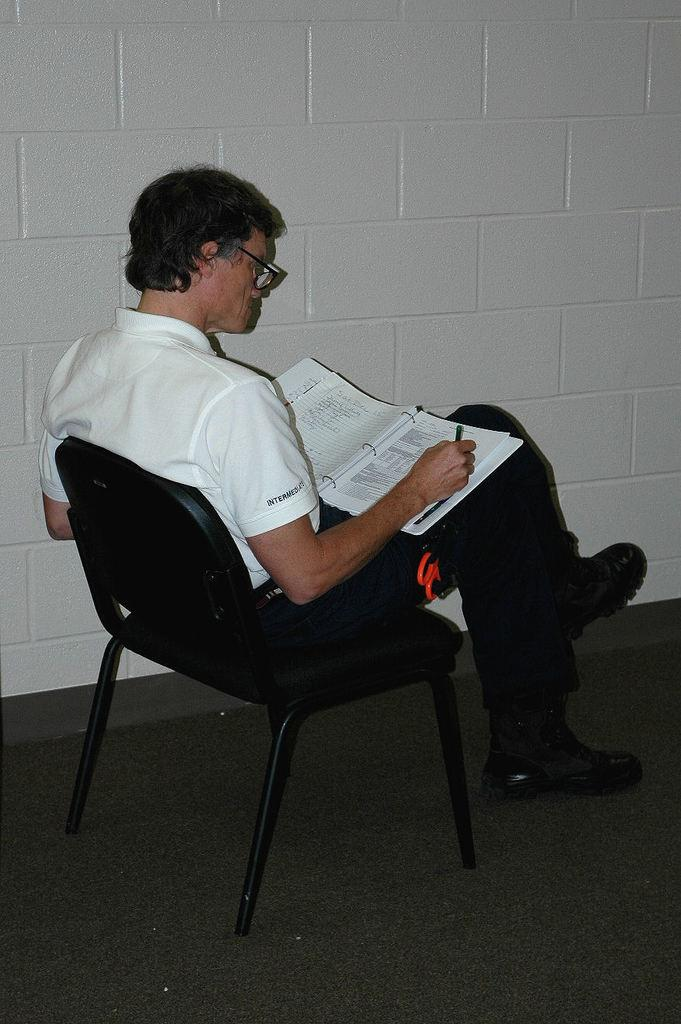Who is present in the image? There is a man in the image. What is the man doing in the image? The man is sitting on a chair and holding a book. What activity is the man engaged in? The man is writing something. What can be seen in the background of the image? There are tiles visible in the background of the image. Reasoning: Let's think step by following the steps to produce the conversation. We start by identifying the main subject in the image, which is the man. Then, we describe his actions and the object he is holding, which is a book. Next, we mention the activity he is engaged in, which is writing. Finally, we include a detail about the background of the image, which is the presence of tiles. Absurd Question/Answer: How many umbrellas are open in the image? There are no umbrellas present in the image, so it is not possible to determine the number of open umbrellas. How many clocks are visible on the wall in the image? There are no clocks visible on the wall in the image. What type of furniture is present in the image? The only furniture mentioned in the image is the chair that the man is sitting on. 